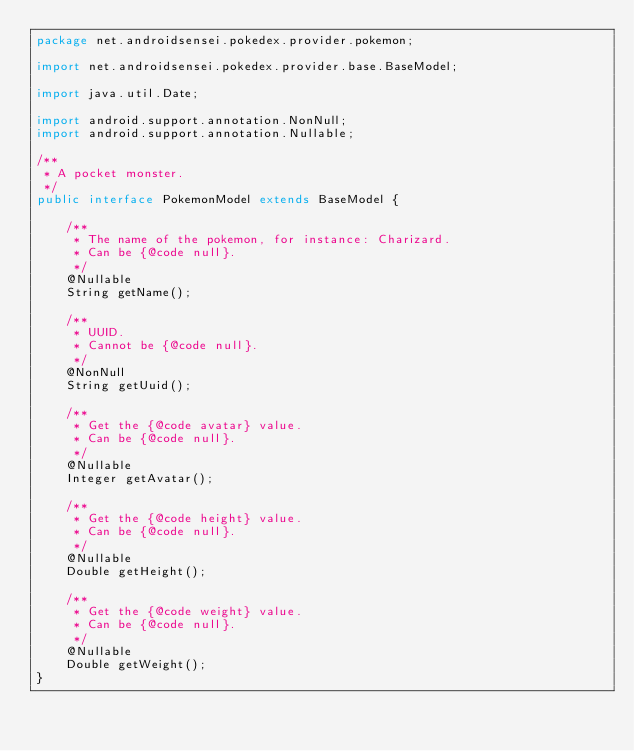<code> <loc_0><loc_0><loc_500><loc_500><_Java_>package net.androidsensei.pokedex.provider.pokemon;

import net.androidsensei.pokedex.provider.base.BaseModel;

import java.util.Date;

import android.support.annotation.NonNull;
import android.support.annotation.Nullable;

/**
 * A pocket monster.
 */
public interface PokemonModel extends BaseModel {

    /**
     * The name of the pokemon, for instance: Charizard.
     * Can be {@code null}.
     */
    @Nullable
    String getName();

    /**
     * UUID.
     * Cannot be {@code null}.
     */
    @NonNull
    String getUuid();

    /**
     * Get the {@code avatar} value.
     * Can be {@code null}.
     */
    @Nullable
    Integer getAvatar();

    /**
     * Get the {@code height} value.
     * Can be {@code null}.
     */
    @Nullable
    Double getHeight();

    /**
     * Get the {@code weight} value.
     * Can be {@code null}.
     */
    @Nullable
    Double getWeight();
}
</code> 